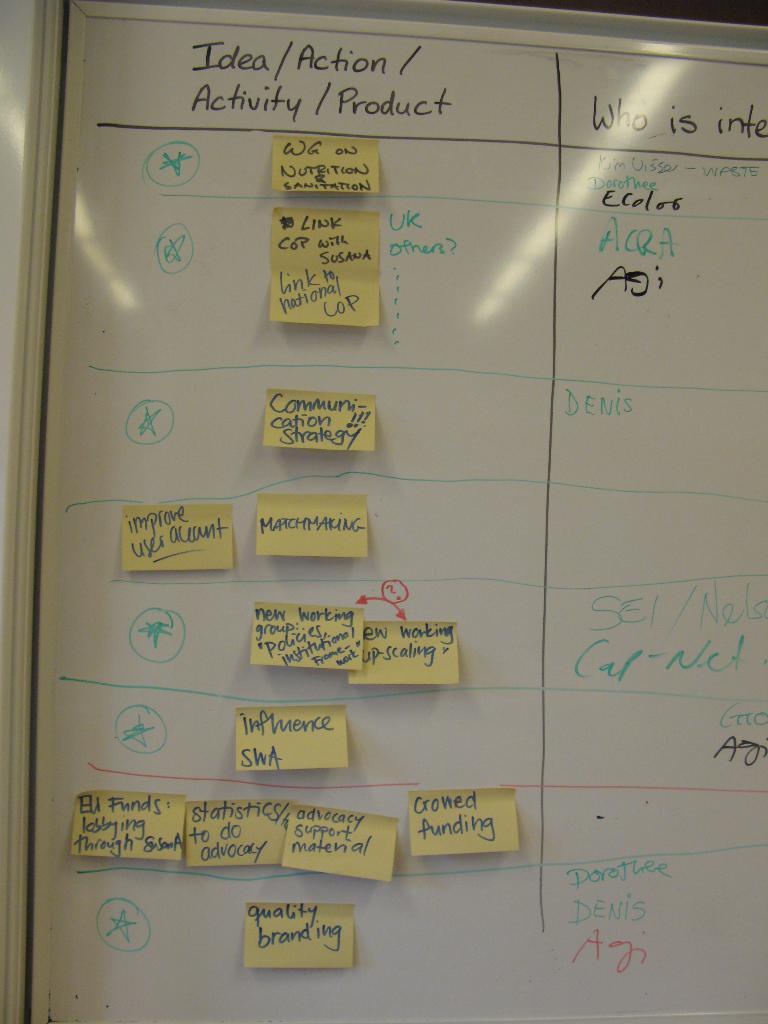What is the first word on the left in the top section of the white board?
Keep it short and to the point. Idea. What is the last sticking note on the bottom say?
Ensure brevity in your answer.  Quality branding. 